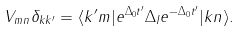<formula> <loc_0><loc_0><loc_500><loc_500>V _ { m n } \delta _ { k k ^ { \prime } } = \langle k ^ { \prime } m | e ^ { \Delta _ { 0 } t ^ { \prime } } \Delta _ { I } e ^ { - \Delta _ { 0 } t ^ { \prime } } | k n \rangle .</formula> 